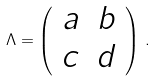Convert formula to latex. <formula><loc_0><loc_0><loc_500><loc_500>\Lambda = \left ( \begin{array} { c c } a & b \\ c & d \end{array} \right ) \, .</formula> 